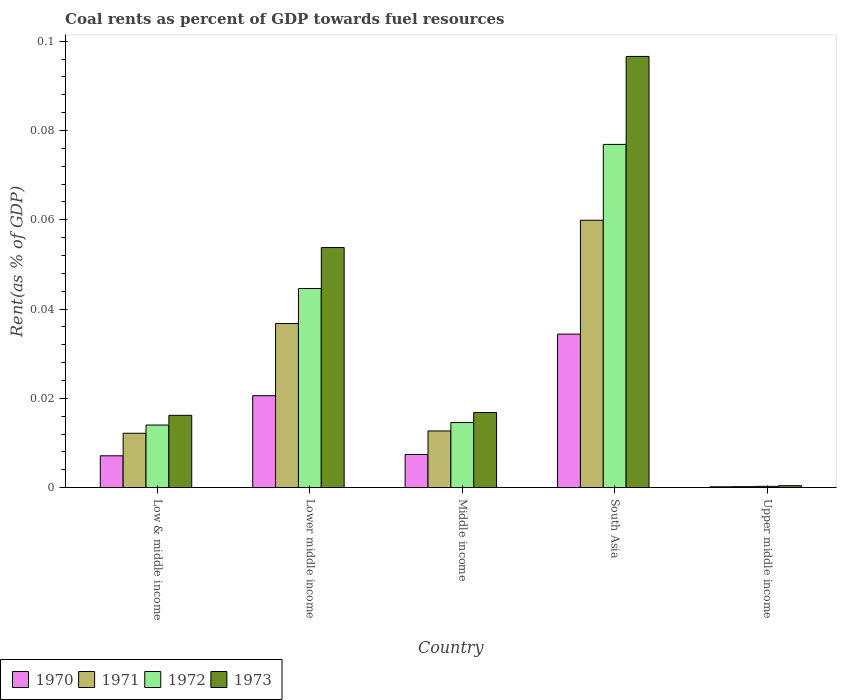How many groups of bars are there?
Your response must be concise. 5. Are the number of bars per tick equal to the number of legend labels?
Ensure brevity in your answer.  Yes. How many bars are there on the 5th tick from the left?
Give a very brief answer. 4. In how many cases, is the number of bars for a given country not equal to the number of legend labels?
Give a very brief answer. 0. What is the coal rent in 1972 in Lower middle income?
Provide a short and direct response. 0.04. Across all countries, what is the maximum coal rent in 1973?
Keep it short and to the point. 0.1. Across all countries, what is the minimum coal rent in 1972?
Your answer should be compact. 0. In which country was the coal rent in 1971 maximum?
Give a very brief answer. South Asia. In which country was the coal rent in 1970 minimum?
Keep it short and to the point. Upper middle income. What is the total coal rent in 1972 in the graph?
Your answer should be compact. 0.15. What is the difference between the coal rent in 1971 in South Asia and that in Upper middle income?
Offer a very short reply. 0.06. What is the difference between the coal rent in 1973 in Low & middle income and the coal rent in 1970 in Middle income?
Offer a very short reply. 0.01. What is the average coal rent in 1970 per country?
Ensure brevity in your answer.  0.01. What is the difference between the coal rent of/in 1972 and coal rent of/in 1973 in Upper middle income?
Give a very brief answer. -0. What is the ratio of the coal rent in 1970 in Middle income to that in South Asia?
Offer a terse response. 0.22. Is the difference between the coal rent in 1972 in Low & middle income and Middle income greater than the difference between the coal rent in 1973 in Low & middle income and Middle income?
Provide a short and direct response. Yes. What is the difference between the highest and the second highest coal rent in 1971?
Make the answer very short. 0.05. What is the difference between the highest and the lowest coal rent in 1972?
Your answer should be compact. 0.08. In how many countries, is the coal rent in 1971 greater than the average coal rent in 1971 taken over all countries?
Ensure brevity in your answer.  2. Is the sum of the coal rent in 1973 in Low & middle income and Lower middle income greater than the maximum coal rent in 1971 across all countries?
Keep it short and to the point. Yes. Is it the case that in every country, the sum of the coal rent in 1970 and coal rent in 1973 is greater than the sum of coal rent in 1971 and coal rent in 1972?
Provide a short and direct response. No. What does the 3rd bar from the left in Lower middle income represents?
Your answer should be compact. 1972. What does the 1st bar from the right in Lower middle income represents?
Give a very brief answer. 1973. Are all the bars in the graph horizontal?
Keep it short and to the point. No. How many legend labels are there?
Keep it short and to the point. 4. How are the legend labels stacked?
Offer a very short reply. Horizontal. What is the title of the graph?
Make the answer very short. Coal rents as percent of GDP towards fuel resources. Does "1986" appear as one of the legend labels in the graph?
Offer a terse response. No. What is the label or title of the X-axis?
Make the answer very short. Country. What is the label or title of the Y-axis?
Give a very brief answer. Rent(as % of GDP). What is the Rent(as % of GDP) in 1970 in Low & middle income?
Ensure brevity in your answer.  0.01. What is the Rent(as % of GDP) of 1971 in Low & middle income?
Provide a succinct answer. 0.01. What is the Rent(as % of GDP) in 1972 in Low & middle income?
Provide a succinct answer. 0.01. What is the Rent(as % of GDP) in 1973 in Low & middle income?
Ensure brevity in your answer.  0.02. What is the Rent(as % of GDP) of 1970 in Lower middle income?
Your response must be concise. 0.02. What is the Rent(as % of GDP) of 1971 in Lower middle income?
Offer a very short reply. 0.04. What is the Rent(as % of GDP) of 1972 in Lower middle income?
Provide a succinct answer. 0.04. What is the Rent(as % of GDP) in 1973 in Lower middle income?
Provide a succinct answer. 0.05. What is the Rent(as % of GDP) of 1970 in Middle income?
Your answer should be very brief. 0.01. What is the Rent(as % of GDP) in 1971 in Middle income?
Provide a short and direct response. 0.01. What is the Rent(as % of GDP) in 1972 in Middle income?
Provide a short and direct response. 0.01. What is the Rent(as % of GDP) of 1973 in Middle income?
Make the answer very short. 0.02. What is the Rent(as % of GDP) in 1970 in South Asia?
Offer a terse response. 0.03. What is the Rent(as % of GDP) of 1971 in South Asia?
Offer a very short reply. 0.06. What is the Rent(as % of GDP) in 1972 in South Asia?
Your answer should be compact. 0.08. What is the Rent(as % of GDP) in 1973 in South Asia?
Offer a very short reply. 0.1. What is the Rent(as % of GDP) in 1970 in Upper middle income?
Offer a terse response. 0. What is the Rent(as % of GDP) of 1971 in Upper middle income?
Provide a succinct answer. 0. What is the Rent(as % of GDP) in 1972 in Upper middle income?
Offer a terse response. 0. What is the Rent(as % of GDP) in 1973 in Upper middle income?
Ensure brevity in your answer.  0. Across all countries, what is the maximum Rent(as % of GDP) of 1970?
Give a very brief answer. 0.03. Across all countries, what is the maximum Rent(as % of GDP) in 1971?
Your answer should be very brief. 0.06. Across all countries, what is the maximum Rent(as % of GDP) of 1972?
Your answer should be very brief. 0.08. Across all countries, what is the maximum Rent(as % of GDP) of 1973?
Make the answer very short. 0.1. Across all countries, what is the minimum Rent(as % of GDP) of 1970?
Make the answer very short. 0. Across all countries, what is the minimum Rent(as % of GDP) in 1971?
Your answer should be very brief. 0. Across all countries, what is the minimum Rent(as % of GDP) in 1972?
Give a very brief answer. 0. Across all countries, what is the minimum Rent(as % of GDP) of 1973?
Keep it short and to the point. 0. What is the total Rent(as % of GDP) of 1970 in the graph?
Offer a very short reply. 0.07. What is the total Rent(as % of GDP) in 1971 in the graph?
Provide a succinct answer. 0.12. What is the total Rent(as % of GDP) in 1972 in the graph?
Offer a terse response. 0.15. What is the total Rent(as % of GDP) in 1973 in the graph?
Provide a short and direct response. 0.18. What is the difference between the Rent(as % of GDP) in 1970 in Low & middle income and that in Lower middle income?
Your answer should be very brief. -0.01. What is the difference between the Rent(as % of GDP) in 1971 in Low & middle income and that in Lower middle income?
Your answer should be very brief. -0.02. What is the difference between the Rent(as % of GDP) of 1972 in Low & middle income and that in Lower middle income?
Your answer should be very brief. -0.03. What is the difference between the Rent(as % of GDP) in 1973 in Low & middle income and that in Lower middle income?
Provide a succinct answer. -0.04. What is the difference between the Rent(as % of GDP) in 1970 in Low & middle income and that in Middle income?
Your answer should be compact. -0. What is the difference between the Rent(as % of GDP) of 1971 in Low & middle income and that in Middle income?
Provide a succinct answer. -0. What is the difference between the Rent(as % of GDP) of 1972 in Low & middle income and that in Middle income?
Your answer should be very brief. -0. What is the difference between the Rent(as % of GDP) in 1973 in Low & middle income and that in Middle income?
Provide a succinct answer. -0. What is the difference between the Rent(as % of GDP) in 1970 in Low & middle income and that in South Asia?
Offer a terse response. -0.03. What is the difference between the Rent(as % of GDP) in 1971 in Low & middle income and that in South Asia?
Keep it short and to the point. -0.05. What is the difference between the Rent(as % of GDP) of 1972 in Low & middle income and that in South Asia?
Ensure brevity in your answer.  -0.06. What is the difference between the Rent(as % of GDP) in 1973 in Low & middle income and that in South Asia?
Offer a very short reply. -0.08. What is the difference between the Rent(as % of GDP) of 1970 in Low & middle income and that in Upper middle income?
Your answer should be compact. 0.01. What is the difference between the Rent(as % of GDP) in 1971 in Low & middle income and that in Upper middle income?
Ensure brevity in your answer.  0.01. What is the difference between the Rent(as % of GDP) in 1972 in Low & middle income and that in Upper middle income?
Provide a short and direct response. 0.01. What is the difference between the Rent(as % of GDP) in 1973 in Low & middle income and that in Upper middle income?
Your answer should be compact. 0.02. What is the difference between the Rent(as % of GDP) of 1970 in Lower middle income and that in Middle income?
Offer a terse response. 0.01. What is the difference between the Rent(as % of GDP) of 1971 in Lower middle income and that in Middle income?
Offer a terse response. 0.02. What is the difference between the Rent(as % of GDP) in 1973 in Lower middle income and that in Middle income?
Offer a very short reply. 0.04. What is the difference between the Rent(as % of GDP) of 1970 in Lower middle income and that in South Asia?
Offer a very short reply. -0.01. What is the difference between the Rent(as % of GDP) of 1971 in Lower middle income and that in South Asia?
Provide a succinct answer. -0.02. What is the difference between the Rent(as % of GDP) in 1972 in Lower middle income and that in South Asia?
Offer a very short reply. -0.03. What is the difference between the Rent(as % of GDP) of 1973 in Lower middle income and that in South Asia?
Provide a succinct answer. -0.04. What is the difference between the Rent(as % of GDP) in 1970 in Lower middle income and that in Upper middle income?
Your answer should be compact. 0.02. What is the difference between the Rent(as % of GDP) in 1971 in Lower middle income and that in Upper middle income?
Provide a short and direct response. 0.04. What is the difference between the Rent(as % of GDP) of 1972 in Lower middle income and that in Upper middle income?
Provide a succinct answer. 0.04. What is the difference between the Rent(as % of GDP) of 1973 in Lower middle income and that in Upper middle income?
Your answer should be very brief. 0.05. What is the difference between the Rent(as % of GDP) in 1970 in Middle income and that in South Asia?
Your answer should be compact. -0.03. What is the difference between the Rent(as % of GDP) of 1971 in Middle income and that in South Asia?
Provide a succinct answer. -0.05. What is the difference between the Rent(as % of GDP) in 1972 in Middle income and that in South Asia?
Offer a terse response. -0.06. What is the difference between the Rent(as % of GDP) in 1973 in Middle income and that in South Asia?
Your answer should be very brief. -0.08. What is the difference between the Rent(as % of GDP) in 1970 in Middle income and that in Upper middle income?
Make the answer very short. 0.01. What is the difference between the Rent(as % of GDP) of 1971 in Middle income and that in Upper middle income?
Keep it short and to the point. 0.01. What is the difference between the Rent(as % of GDP) of 1972 in Middle income and that in Upper middle income?
Keep it short and to the point. 0.01. What is the difference between the Rent(as % of GDP) of 1973 in Middle income and that in Upper middle income?
Make the answer very short. 0.02. What is the difference between the Rent(as % of GDP) of 1970 in South Asia and that in Upper middle income?
Provide a succinct answer. 0.03. What is the difference between the Rent(as % of GDP) of 1971 in South Asia and that in Upper middle income?
Your response must be concise. 0.06. What is the difference between the Rent(as % of GDP) of 1972 in South Asia and that in Upper middle income?
Your response must be concise. 0.08. What is the difference between the Rent(as % of GDP) of 1973 in South Asia and that in Upper middle income?
Offer a very short reply. 0.1. What is the difference between the Rent(as % of GDP) of 1970 in Low & middle income and the Rent(as % of GDP) of 1971 in Lower middle income?
Offer a terse response. -0.03. What is the difference between the Rent(as % of GDP) of 1970 in Low & middle income and the Rent(as % of GDP) of 1972 in Lower middle income?
Your answer should be very brief. -0.04. What is the difference between the Rent(as % of GDP) of 1970 in Low & middle income and the Rent(as % of GDP) of 1973 in Lower middle income?
Make the answer very short. -0.05. What is the difference between the Rent(as % of GDP) of 1971 in Low & middle income and the Rent(as % of GDP) of 1972 in Lower middle income?
Your answer should be compact. -0.03. What is the difference between the Rent(as % of GDP) of 1971 in Low & middle income and the Rent(as % of GDP) of 1973 in Lower middle income?
Give a very brief answer. -0.04. What is the difference between the Rent(as % of GDP) in 1972 in Low & middle income and the Rent(as % of GDP) in 1973 in Lower middle income?
Provide a short and direct response. -0.04. What is the difference between the Rent(as % of GDP) of 1970 in Low & middle income and the Rent(as % of GDP) of 1971 in Middle income?
Give a very brief answer. -0.01. What is the difference between the Rent(as % of GDP) of 1970 in Low & middle income and the Rent(as % of GDP) of 1972 in Middle income?
Give a very brief answer. -0.01. What is the difference between the Rent(as % of GDP) in 1970 in Low & middle income and the Rent(as % of GDP) in 1973 in Middle income?
Provide a succinct answer. -0.01. What is the difference between the Rent(as % of GDP) of 1971 in Low & middle income and the Rent(as % of GDP) of 1972 in Middle income?
Your response must be concise. -0. What is the difference between the Rent(as % of GDP) of 1971 in Low & middle income and the Rent(as % of GDP) of 1973 in Middle income?
Make the answer very short. -0. What is the difference between the Rent(as % of GDP) in 1972 in Low & middle income and the Rent(as % of GDP) in 1973 in Middle income?
Provide a short and direct response. -0. What is the difference between the Rent(as % of GDP) in 1970 in Low & middle income and the Rent(as % of GDP) in 1971 in South Asia?
Provide a short and direct response. -0.05. What is the difference between the Rent(as % of GDP) of 1970 in Low & middle income and the Rent(as % of GDP) of 1972 in South Asia?
Offer a very short reply. -0.07. What is the difference between the Rent(as % of GDP) in 1970 in Low & middle income and the Rent(as % of GDP) in 1973 in South Asia?
Give a very brief answer. -0.09. What is the difference between the Rent(as % of GDP) in 1971 in Low & middle income and the Rent(as % of GDP) in 1972 in South Asia?
Provide a short and direct response. -0.06. What is the difference between the Rent(as % of GDP) of 1971 in Low & middle income and the Rent(as % of GDP) of 1973 in South Asia?
Your response must be concise. -0.08. What is the difference between the Rent(as % of GDP) of 1972 in Low & middle income and the Rent(as % of GDP) of 1973 in South Asia?
Offer a very short reply. -0.08. What is the difference between the Rent(as % of GDP) in 1970 in Low & middle income and the Rent(as % of GDP) in 1971 in Upper middle income?
Keep it short and to the point. 0.01. What is the difference between the Rent(as % of GDP) of 1970 in Low & middle income and the Rent(as % of GDP) of 1972 in Upper middle income?
Offer a terse response. 0.01. What is the difference between the Rent(as % of GDP) in 1970 in Low & middle income and the Rent(as % of GDP) in 1973 in Upper middle income?
Provide a short and direct response. 0.01. What is the difference between the Rent(as % of GDP) of 1971 in Low & middle income and the Rent(as % of GDP) of 1972 in Upper middle income?
Ensure brevity in your answer.  0.01. What is the difference between the Rent(as % of GDP) in 1971 in Low & middle income and the Rent(as % of GDP) in 1973 in Upper middle income?
Keep it short and to the point. 0.01. What is the difference between the Rent(as % of GDP) of 1972 in Low & middle income and the Rent(as % of GDP) of 1973 in Upper middle income?
Offer a terse response. 0.01. What is the difference between the Rent(as % of GDP) in 1970 in Lower middle income and the Rent(as % of GDP) in 1971 in Middle income?
Your answer should be compact. 0.01. What is the difference between the Rent(as % of GDP) in 1970 in Lower middle income and the Rent(as % of GDP) in 1972 in Middle income?
Offer a very short reply. 0.01. What is the difference between the Rent(as % of GDP) in 1970 in Lower middle income and the Rent(as % of GDP) in 1973 in Middle income?
Keep it short and to the point. 0. What is the difference between the Rent(as % of GDP) in 1971 in Lower middle income and the Rent(as % of GDP) in 1972 in Middle income?
Offer a very short reply. 0.02. What is the difference between the Rent(as % of GDP) in 1971 in Lower middle income and the Rent(as % of GDP) in 1973 in Middle income?
Ensure brevity in your answer.  0.02. What is the difference between the Rent(as % of GDP) in 1972 in Lower middle income and the Rent(as % of GDP) in 1973 in Middle income?
Make the answer very short. 0.03. What is the difference between the Rent(as % of GDP) in 1970 in Lower middle income and the Rent(as % of GDP) in 1971 in South Asia?
Make the answer very short. -0.04. What is the difference between the Rent(as % of GDP) of 1970 in Lower middle income and the Rent(as % of GDP) of 1972 in South Asia?
Provide a short and direct response. -0.06. What is the difference between the Rent(as % of GDP) of 1970 in Lower middle income and the Rent(as % of GDP) of 1973 in South Asia?
Provide a short and direct response. -0.08. What is the difference between the Rent(as % of GDP) of 1971 in Lower middle income and the Rent(as % of GDP) of 1972 in South Asia?
Your answer should be very brief. -0.04. What is the difference between the Rent(as % of GDP) in 1971 in Lower middle income and the Rent(as % of GDP) in 1973 in South Asia?
Offer a terse response. -0.06. What is the difference between the Rent(as % of GDP) in 1972 in Lower middle income and the Rent(as % of GDP) in 1973 in South Asia?
Give a very brief answer. -0.05. What is the difference between the Rent(as % of GDP) of 1970 in Lower middle income and the Rent(as % of GDP) of 1971 in Upper middle income?
Your answer should be compact. 0.02. What is the difference between the Rent(as % of GDP) in 1970 in Lower middle income and the Rent(as % of GDP) in 1972 in Upper middle income?
Make the answer very short. 0.02. What is the difference between the Rent(as % of GDP) of 1970 in Lower middle income and the Rent(as % of GDP) of 1973 in Upper middle income?
Ensure brevity in your answer.  0.02. What is the difference between the Rent(as % of GDP) in 1971 in Lower middle income and the Rent(as % of GDP) in 1972 in Upper middle income?
Make the answer very short. 0.04. What is the difference between the Rent(as % of GDP) in 1971 in Lower middle income and the Rent(as % of GDP) in 1973 in Upper middle income?
Your answer should be compact. 0.04. What is the difference between the Rent(as % of GDP) in 1972 in Lower middle income and the Rent(as % of GDP) in 1973 in Upper middle income?
Offer a very short reply. 0.04. What is the difference between the Rent(as % of GDP) of 1970 in Middle income and the Rent(as % of GDP) of 1971 in South Asia?
Provide a short and direct response. -0.05. What is the difference between the Rent(as % of GDP) in 1970 in Middle income and the Rent(as % of GDP) in 1972 in South Asia?
Your answer should be very brief. -0.07. What is the difference between the Rent(as % of GDP) in 1970 in Middle income and the Rent(as % of GDP) in 1973 in South Asia?
Keep it short and to the point. -0.09. What is the difference between the Rent(as % of GDP) in 1971 in Middle income and the Rent(as % of GDP) in 1972 in South Asia?
Provide a short and direct response. -0.06. What is the difference between the Rent(as % of GDP) in 1971 in Middle income and the Rent(as % of GDP) in 1973 in South Asia?
Offer a very short reply. -0.08. What is the difference between the Rent(as % of GDP) in 1972 in Middle income and the Rent(as % of GDP) in 1973 in South Asia?
Provide a succinct answer. -0.08. What is the difference between the Rent(as % of GDP) in 1970 in Middle income and the Rent(as % of GDP) in 1971 in Upper middle income?
Ensure brevity in your answer.  0.01. What is the difference between the Rent(as % of GDP) in 1970 in Middle income and the Rent(as % of GDP) in 1972 in Upper middle income?
Offer a very short reply. 0.01. What is the difference between the Rent(as % of GDP) in 1970 in Middle income and the Rent(as % of GDP) in 1973 in Upper middle income?
Your answer should be compact. 0.01. What is the difference between the Rent(as % of GDP) in 1971 in Middle income and the Rent(as % of GDP) in 1972 in Upper middle income?
Your answer should be compact. 0.01. What is the difference between the Rent(as % of GDP) in 1971 in Middle income and the Rent(as % of GDP) in 1973 in Upper middle income?
Ensure brevity in your answer.  0.01. What is the difference between the Rent(as % of GDP) in 1972 in Middle income and the Rent(as % of GDP) in 1973 in Upper middle income?
Ensure brevity in your answer.  0.01. What is the difference between the Rent(as % of GDP) in 1970 in South Asia and the Rent(as % of GDP) in 1971 in Upper middle income?
Keep it short and to the point. 0.03. What is the difference between the Rent(as % of GDP) of 1970 in South Asia and the Rent(as % of GDP) of 1972 in Upper middle income?
Provide a short and direct response. 0.03. What is the difference between the Rent(as % of GDP) in 1970 in South Asia and the Rent(as % of GDP) in 1973 in Upper middle income?
Offer a very short reply. 0.03. What is the difference between the Rent(as % of GDP) of 1971 in South Asia and the Rent(as % of GDP) of 1972 in Upper middle income?
Provide a short and direct response. 0.06. What is the difference between the Rent(as % of GDP) of 1971 in South Asia and the Rent(as % of GDP) of 1973 in Upper middle income?
Your response must be concise. 0.06. What is the difference between the Rent(as % of GDP) of 1972 in South Asia and the Rent(as % of GDP) of 1973 in Upper middle income?
Offer a very short reply. 0.08. What is the average Rent(as % of GDP) of 1970 per country?
Ensure brevity in your answer.  0.01. What is the average Rent(as % of GDP) in 1971 per country?
Offer a very short reply. 0.02. What is the average Rent(as % of GDP) of 1972 per country?
Keep it short and to the point. 0.03. What is the average Rent(as % of GDP) of 1973 per country?
Provide a short and direct response. 0.04. What is the difference between the Rent(as % of GDP) in 1970 and Rent(as % of GDP) in 1971 in Low & middle income?
Your answer should be compact. -0.01. What is the difference between the Rent(as % of GDP) of 1970 and Rent(as % of GDP) of 1972 in Low & middle income?
Your answer should be very brief. -0.01. What is the difference between the Rent(as % of GDP) in 1970 and Rent(as % of GDP) in 1973 in Low & middle income?
Provide a short and direct response. -0.01. What is the difference between the Rent(as % of GDP) in 1971 and Rent(as % of GDP) in 1972 in Low & middle income?
Ensure brevity in your answer.  -0. What is the difference between the Rent(as % of GDP) of 1971 and Rent(as % of GDP) of 1973 in Low & middle income?
Your answer should be compact. -0. What is the difference between the Rent(as % of GDP) of 1972 and Rent(as % of GDP) of 1973 in Low & middle income?
Provide a short and direct response. -0. What is the difference between the Rent(as % of GDP) in 1970 and Rent(as % of GDP) in 1971 in Lower middle income?
Provide a short and direct response. -0.02. What is the difference between the Rent(as % of GDP) in 1970 and Rent(as % of GDP) in 1972 in Lower middle income?
Give a very brief answer. -0.02. What is the difference between the Rent(as % of GDP) of 1970 and Rent(as % of GDP) of 1973 in Lower middle income?
Your answer should be very brief. -0.03. What is the difference between the Rent(as % of GDP) in 1971 and Rent(as % of GDP) in 1972 in Lower middle income?
Offer a terse response. -0.01. What is the difference between the Rent(as % of GDP) in 1971 and Rent(as % of GDP) in 1973 in Lower middle income?
Make the answer very short. -0.02. What is the difference between the Rent(as % of GDP) of 1972 and Rent(as % of GDP) of 1973 in Lower middle income?
Keep it short and to the point. -0.01. What is the difference between the Rent(as % of GDP) of 1970 and Rent(as % of GDP) of 1971 in Middle income?
Your response must be concise. -0.01. What is the difference between the Rent(as % of GDP) of 1970 and Rent(as % of GDP) of 1972 in Middle income?
Provide a short and direct response. -0.01. What is the difference between the Rent(as % of GDP) of 1970 and Rent(as % of GDP) of 1973 in Middle income?
Your response must be concise. -0.01. What is the difference between the Rent(as % of GDP) of 1971 and Rent(as % of GDP) of 1972 in Middle income?
Your answer should be compact. -0. What is the difference between the Rent(as % of GDP) in 1971 and Rent(as % of GDP) in 1973 in Middle income?
Your response must be concise. -0. What is the difference between the Rent(as % of GDP) of 1972 and Rent(as % of GDP) of 1973 in Middle income?
Provide a short and direct response. -0. What is the difference between the Rent(as % of GDP) of 1970 and Rent(as % of GDP) of 1971 in South Asia?
Offer a very short reply. -0.03. What is the difference between the Rent(as % of GDP) in 1970 and Rent(as % of GDP) in 1972 in South Asia?
Offer a terse response. -0.04. What is the difference between the Rent(as % of GDP) in 1970 and Rent(as % of GDP) in 1973 in South Asia?
Offer a terse response. -0.06. What is the difference between the Rent(as % of GDP) of 1971 and Rent(as % of GDP) of 1972 in South Asia?
Make the answer very short. -0.02. What is the difference between the Rent(as % of GDP) in 1971 and Rent(as % of GDP) in 1973 in South Asia?
Offer a very short reply. -0.04. What is the difference between the Rent(as % of GDP) of 1972 and Rent(as % of GDP) of 1973 in South Asia?
Keep it short and to the point. -0.02. What is the difference between the Rent(as % of GDP) of 1970 and Rent(as % of GDP) of 1971 in Upper middle income?
Offer a very short reply. -0. What is the difference between the Rent(as % of GDP) of 1970 and Rent(as % of GDP) of 1972 in Upper middle income?
Keep it short and to the point. -0. What is the difference between the Rent(as % of GDP) of 1970 and Rent(as % of GDP) of 1973 in Upper middle income?
Your answer should be compact. -0. What is the difference between the Rent(as % of GDP) in 1971 and Rent(as % of GDP) in 1972 in Upper middle income?
Make the answer very short. -0. What is the difference between the Rent(as % of GDP) of 1971 and Rent(as % of GDP) of 1973 in Upper middle income?
Ensure brevity in your answer.  -0. What is the difference between the Rent(as % of GDP) in 1972 and Rent(as % of GDP) in 1973 in Upper middle income?
Provide a succinct answer. -0. What is the ratio of the Rent(as % of GDP) in 1970 in Low & middle income to that in Lower middle income?
Your answer should be compact. 0.35. What is the ratio of the Rent(as % of GDP) in 1971 in Low & middle income to that in Lower middle income?
Your response must be concise. 0.33. What is the ratio of the Rent(as % of GDP) of 1972 in Low & middle income to that in Lower middle income?
Provide a short and direct response. 0.31. What is the ratio of the Rent(as % of GDP) in 1973 in Low & middle income to that in Lower middle income?
Offer a very short reply. 0.3. What is the ratio of the Rent(as % of GDP) of 1970 in Low & middle income to that in Middle income?
Ensure brevity in your answer.  0.96. What is the ratio of the Rent(as % of GDP) in 1971 in Low & middle income to that in Middle income?
Keep it short and to the point. 0.96. What is the ratio of the Rent(as % of GDP) in 1972 in Low & middle income to that in Middle income?
Make the answer very short. 0.96. What is the ratio of the Rent(as % of GDP) in 1973 in Low & middle income to that in Middle income?
Provide a succinct answer. 0.96. What is the ratio of the Rent(as % of GDP) of 1970 in Low & middle income to that in South Asia?
Your answer should be compact. 0.21. What is the ratio of the Rent(as % of GDP) in 1971 in Low & middle income to that in South Asia?
Your response must be concise. 0.2. What is the ratio of the Rent(as % of GDP) in 1972 in Low & middle income to that in South Asia?
Your answer should be compact. 0.18. What is the ratio of the Rent(as % of GDP) of 1973 in Low & middle income to that in South Asia?
Make the answer very short. 0.17. What is the ratio of the Rent(as % of GDP) in 1970 in Low & middle income to that in Upper middle income?
Give a very brief answer. 38.77. What is the ratio of the Rent(as % of GDP) in 1971 in Low & middle income to that in Upper middle income?
Ensure brevity in your answer.  55.66. What is the ratio of the Rent(as % of GDP) in 1972 in Low & middle income to that in Upper middle income?
Make the answer very short. 49.28. What is the ratio of the Rent(as % of GDP) in 1973 in Low & middle income to that in Upper middle income?
Give a very brief answer. 37.59. What is the ratio of the Rent(as % of GDP) of 1970 in Lower middle income to that in Middle income?
Provide a succinct answer. 2.78. What is the ratio of the Rent(as % of GDP) of 1971 in Lower middle income to that in Middle income?
Give a very brief answer. 2.9. What is the ratio of the Rent(as % of GDP) of 1972 in Lower middle income to that in Middle income?
Offer a terse response. 3.06. What is the ratio of the Rent(as % of GDP) of 1973 in Lower middle income to that in Middle income?
Your answer should be compact. 3.2. What is the ratio of the Rent(as % of GDP) in 1970 in Lower middle income to that in South Asia?
Provide a short and direct response. 0.6. What is the ratio of the Rent(as % of GDP) of 1971 in Lower middle income to that in South Asia?
Your response must be concise. 0.61. What is the ratio of the Rent(as % of GDP) in 1972 in Lower middle income to that in South Asia?
Your answer should be very brief. 0.58. What is the ratio of the Rent(as % of GDP) of 1973 in Lower middle income to that in South Asia?
Provide a succinct answer. 0.56. What is the ratio of the Rent(as % of GDP) of 1970 in Lower middle income to that in Upper middle income?
Your response must be concise. 112.03. What is the ratio of the Rent(as % of GDP) of 1971 in Lower middle income to that in Upper middle income?
Your answer should be very brief. 167.98. What is the ratio of the Rent(as % of GDP) of 1972 in Lower middle income to that in Upper middle income?
Offer a terse response. 156.82. What is the ratio of the Rent(as % of GDP) of 1973 in Lower middle income to that in Upper middle income?
Make the answer very short. 124.82. What is the ratio of the Rent(as % of GDP) of 1970 in Middle income to that in South Asia?
Your response must be concise. 0.22. What is the ratio of the Rent(as % of GDP) of 1971 in Middle income to that in South Asia?
Make the answer very short. 0.21. What is the ratio of the Rent(as % of GDP) of 1972 in Middle income to that in South Asia?
Offer a very short reply. 0.19. What is the ratio of the Rent(as % of GDP) of 1973 in Middle income to that in South Asia?
Your response must be concise. 0.17. What is the ratio of the Rent(as % of GDP) of 1970 in Middle income to that in Upper middle income?
Ensure brevity in your answer.  40.36. What is the ratio of the Rent(as % of GDP) in 1971 in Middle income to that in Upper middle income?
Keep it short and to the point. 58.01. What is the ratio of the Rent(as % of GDP) of 1972 in Middle income to that in Upper middle income?
Offer a terse response. 51.25. What is the ratio of the Rent(as % of GDP) in 1973 in Middle income to that in Upper middle income?
Offer a terse response. 39.04. What is the ratio of the Rent(as % of GDP) of 1970 in South Asia to that in Upper middle income?
Your response must be concise. 187.05. What is the ratio of the Rent(as % of GDP) of 1971 in South Asia to that in Upper middle income?
Your answer should be very brief. 273.74. What is the ratio of the Rent(as % of GDP) of 1972 in South Asia to that in Upper middle income?
Keep it short and to the point. 270.32. What is the ratio of the Rent(as % of GDP) in 1973 in South Asia to that in Upper middle income?
Offer a very short reply. 224.18. What is the difference between the highest and the second highest Rent(as % of GDP) of 1970?
Make the answer very short. 0.01. What is the difference between the highest and the second highest Rent(as % of GDP) in 1971?
Your answer should be very brief. 0.02. What is the difference between the highest and the second highest Rent(as % of GDP) of 1972?
Provide a succinct answer. 0.03. What is the difference between the highest and the second highest Rent(as % of GDP) in 1973?
Provide a succinct answer. 0.04. What is the difference between the highest and the lowest Rent(as % of GDP) in 1970?
Ensure brevity in your answer.  0.03. What is the difference between the highest and the lowest Rent(as % of GDP) of 1971?
Your response must be concise. 0.06. What is the difference between the highest and the lowest Rent(as % of GDP) in 1972?
Make the answer very short. 0.08. What is the difference between the highest and the lowest Rent(as % of GDP) of 1973?
Give a very brief answer. 0.1. 